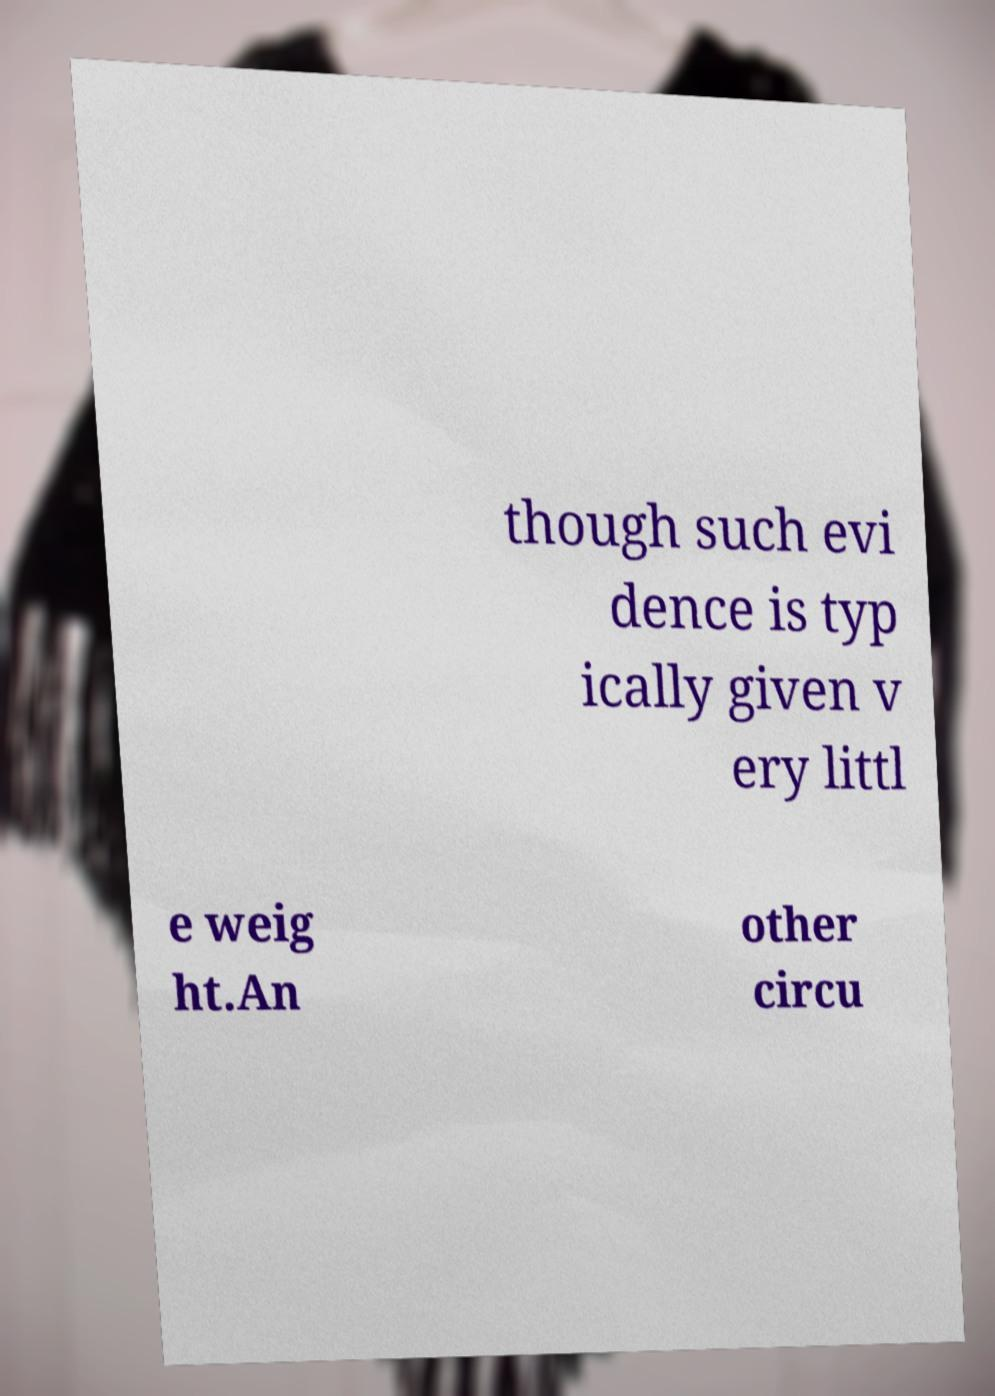Could you extract and type out the text from this image? though such evi dence is typ ically given v ery littl e weig ht.An other circu 